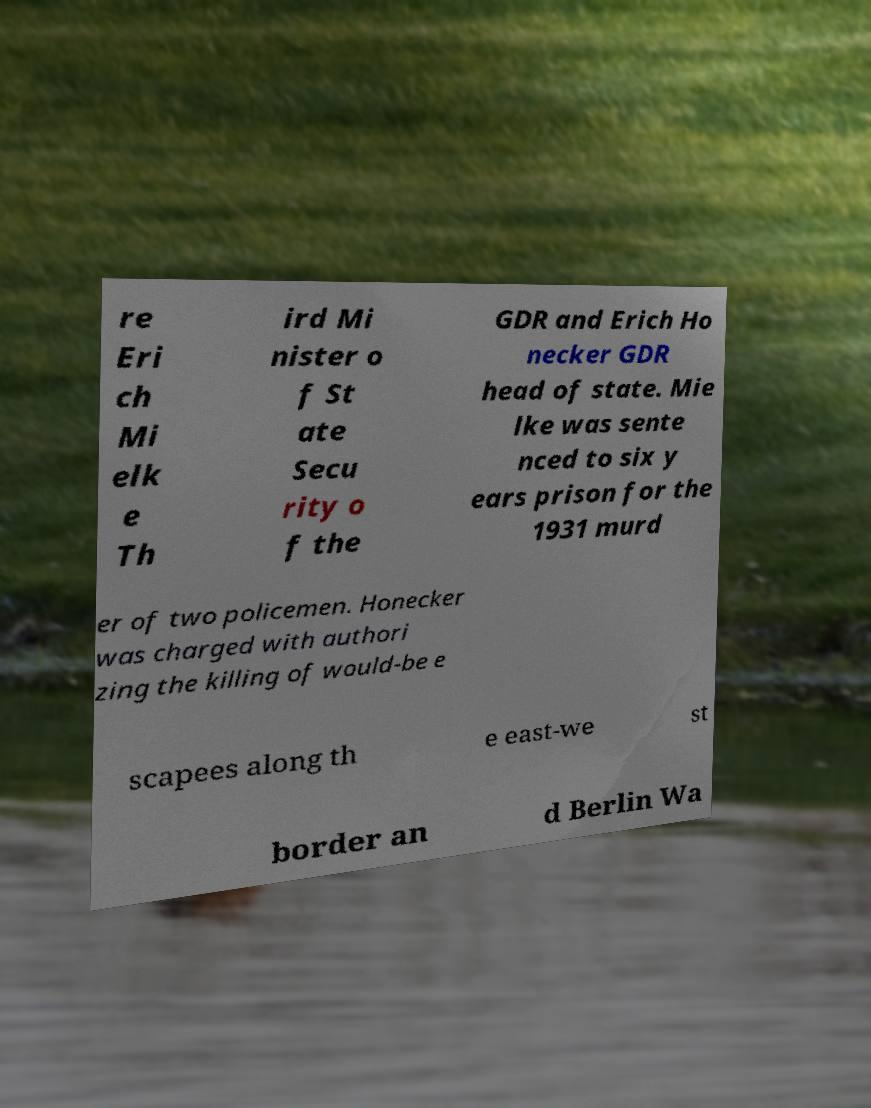Please read and relay the text visible in this image. What does it say? re Eri ch Mi elk e Th ird Mi nister o f St ate Secu rity o f the GDR and Erich Ho necker GDR head of state. Mie lke was sente nced to six y ears prison for the 1931 murd er of two policemen. Honecker was charged with authori zing the killing of would-be e scapees along th e east-we st border an d Berlin Wa 